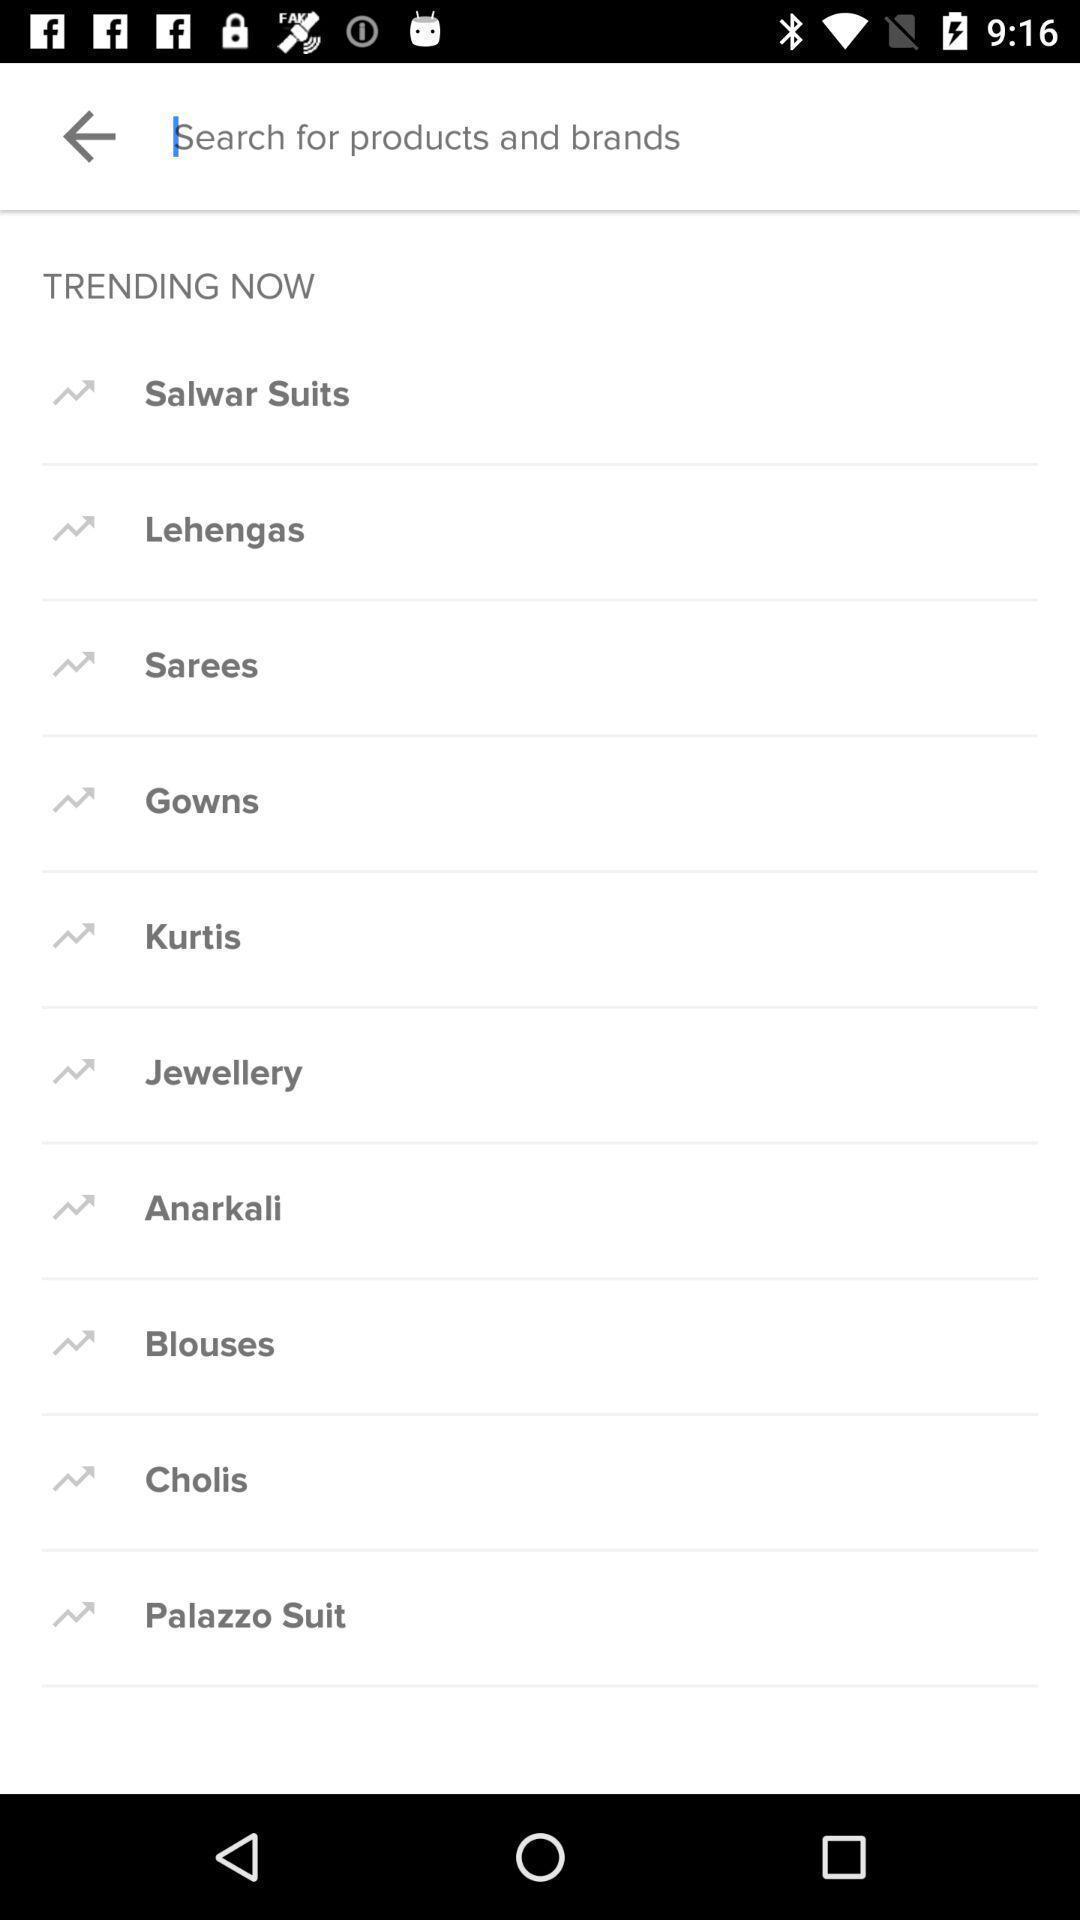Describe the visual elements of this screenshot. Search page of a shopping app. 